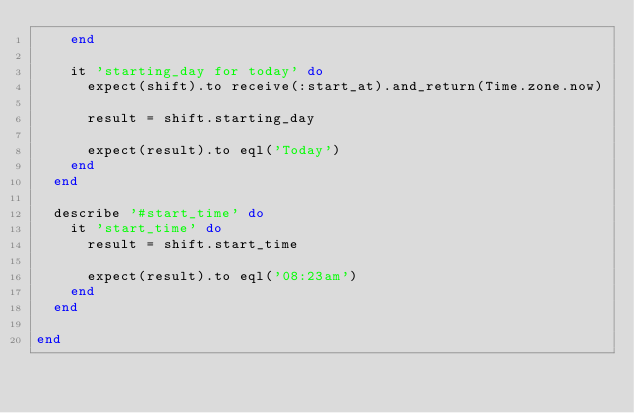Convert code to text. <code><loc_0><loc_0><loc_500><loc_500><_Ruby_>    end

    it 'starting_day for today' do
      expect(shift).to receive(:start_at).and_return(Time.zone.now)

      result = shift.starting_day

      expect(result).to eql('Today')
    end
  end

  describe '#start_time' do
    it 'start_time' do
      result = shift.start_time

      expect(result).to eql('08:23am')
    end
  end

end
</code> 